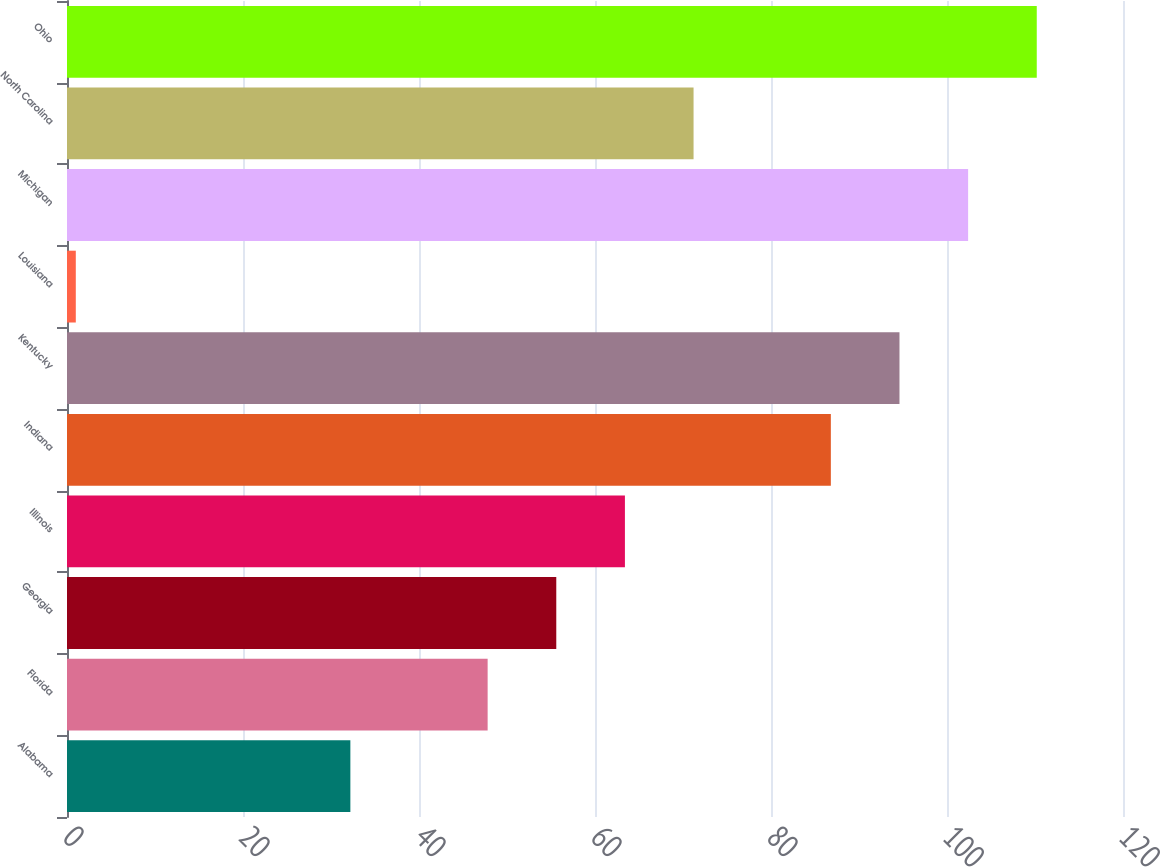Convert chart. <chart><loc_0><loc_0><loc_500><loc_500><bar_chart><fcel>Alabama<fcel>Florida<fcel>Georgia<fcel>Illinois<fcel>Indiana<fcel>Kentucky<fcel>Louisiana<fcel>Michigan<fcel>North Carolina<fcel>Ohio<nl><fcel>32.2<fcel>47.8<fcel>55.6<fcel>63.4<fcel>86.8<fcel>94.6<fcel>1<fcel>102.4<fcel>71.2<fcel>110.2<nl></chart> 